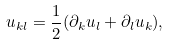Convert formula to latex. <formula><loc_0><loc_0><loc_500><loc_500>u _ { k l } = \frac { 1 } { 2 } ( \partial _ { k } u _ { l } + \partial _ { l } u _ { k } ) ,</formula> 